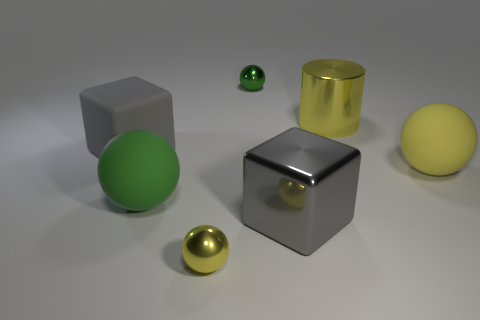Subtract all small yellow spheres. How many spheres are left? 3 Subtract all cyan blocks. How many green balls are left? 2 Subtract all red balls. Subtract all brown cubes. How many balls are left? 4 Add 2 cylinders. How many objects exist? 9 Subtract all cylinders. How many objects are left? 6 Add 5 green rubber spheres. How many green rubber spheres are left? 6 Add 4 red shiny cylinders. How many red shiny cylinders exist? 4 Subtract 0 cyan spheres. How many objects are left? 7 Subtract all large metal objects. Subtract all red cubes. How many objects are left? 5 